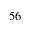<formula> <loc_0><loc_0><loc_500><loc_500>5 6</formula> 